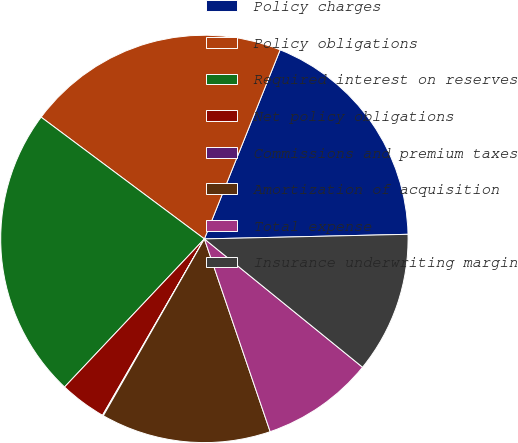Convert chart to OTSL. <chart><loc_0><loc_0><loc_500><loc_500><pie_chart><fcel>Policy charges<fcel>Policy obligations<fcel>Required interest on reserves<fcel>Net policy obligations<fcel>Commissions and premium taxes<fcel>Amortization of acquisition<fcel>Total expense<fcel>Insurance underwriting margin<nl><fcel>18.58%<fcel>20.87%<fcel>23.16%<fcel>3.71%<fcel>0.07%<fcel>13.5%<fcel>8.92%<fcel>11.21%<nl></chart> 